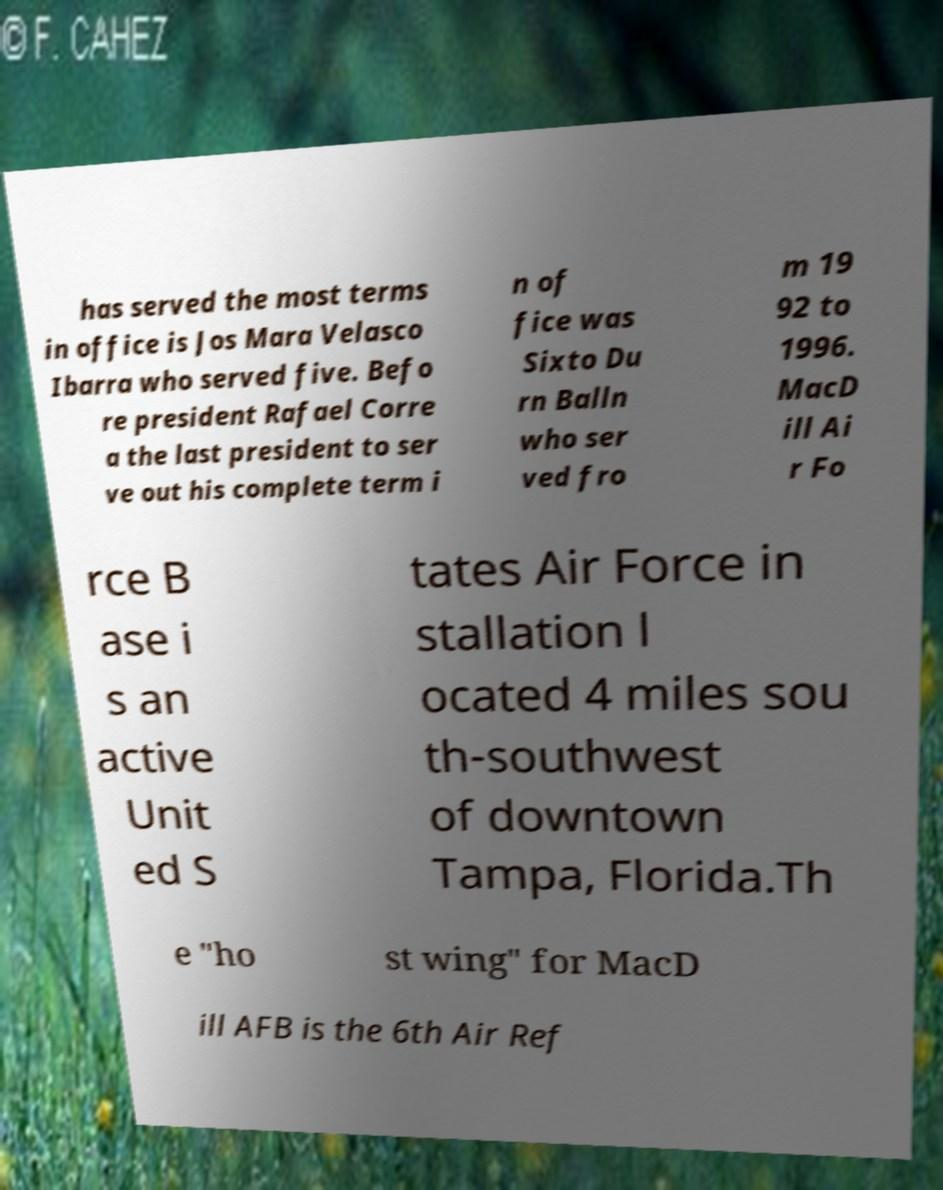Can you read and provide the text displayed in the image?This photo seems to have some interesting text. Can you extract and type it out for me? has served the most terms in office is Jos Mara Velasco Ibarra who served five. Befo re president Rafael Corre a the last president to ser ve out his complete term i n of fice was Sixto Du rn Balln who ser ved fro m 19 92 to 1996. MacD ill Ai r Fo rce B ase i s an active Unit ed S tates Air Force in stallation l ocated 4 miles sou th-southwest of downtown Tampa, Florida.Th e "ho st wing" for MacD ill AFB is the 6th Air Ref 